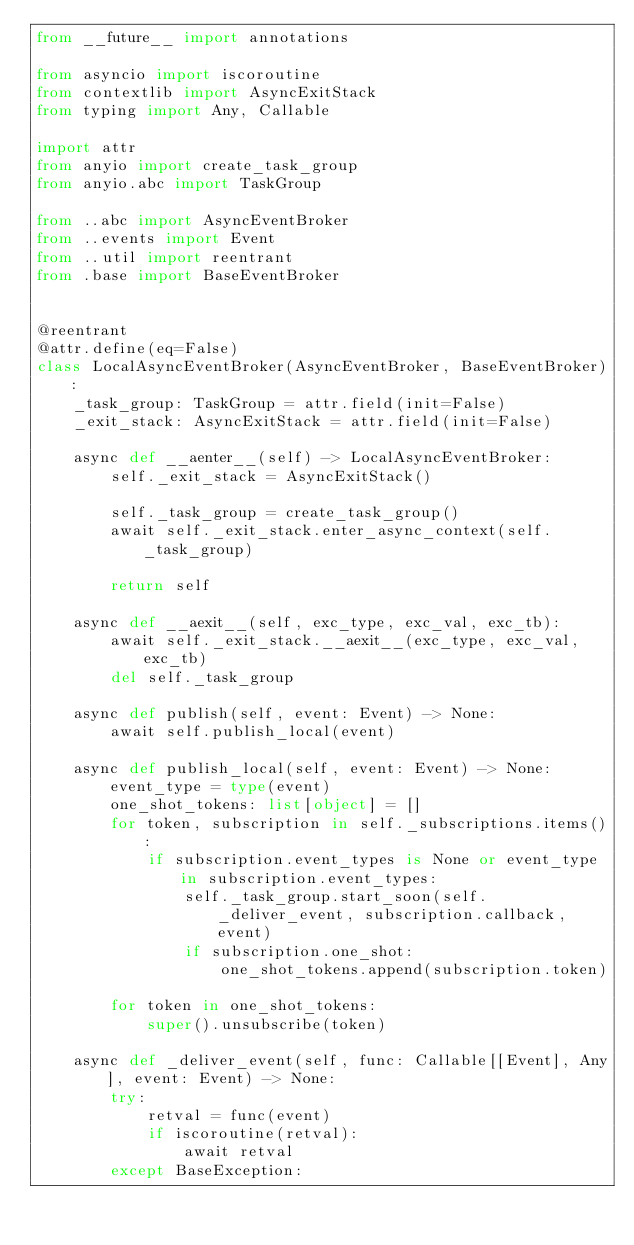<code> <loc_0><loc_0><loc_500><loc_500><_Python_>from __future__ import annotations

from asyncio import iscoroutine
from contextlib import AsyncExitStack
from typing import Any, Callable

import attr
from anyio import create_task_group
from anyio.abc import TaskGroup

from ..abc import AsyncEventBroker
from ..events import Event
from ..util import reentrant
from .base import BaseEventBroker


@reentrant
@attr.define(eq=False)
class LocalAsyncEventBroker(AsyncEventBroker, BaseEventBroker):
    _task_group: TaskGroup = attr.field(init=False)
    _exit_stack: AsyncExitStack = attr.field(init=False)

    async def __aenter__(self) -> LocalAsyncEventBroker:
        self._exit_stack = AsyncExitStack()

        self._task_group = create_task_group()
        await self._exit_stack.enter_async_context(self._task_group)

        return self

    async def __aexit__(self, exc_type, exc_val, exc_tb):
        await self._exit_stack.__aexit__(exc_type, exc_val, exc_tb)
        del self._task_group

    async def publish(self, event: Event) -> None:
        await self.publish_local(event)

    async def publish_local(self, event: Event) -> None:
        event_type = type(event)
        one_shot_tokens: list[object] = []
        for token, subscription in self._subscriptions.items():
            if subscription.event_types is None or event_type in subscription.event_types:
                self._task_group.start_soon(self._deliver_event, subscription.callback, event)
                if subscription.one_shot:
                    one_shot_tokens.append(subscription.token)

        for token in one_shot_tokens:
            super().unsubscribe(token)

    async def _deliver_event(self, func: Callable[[Event], Any], event: Event) -> None:
        try:
            retval = func(event)
            if iscoroutine(retval):
                await retval
        except BaseException:</code> 